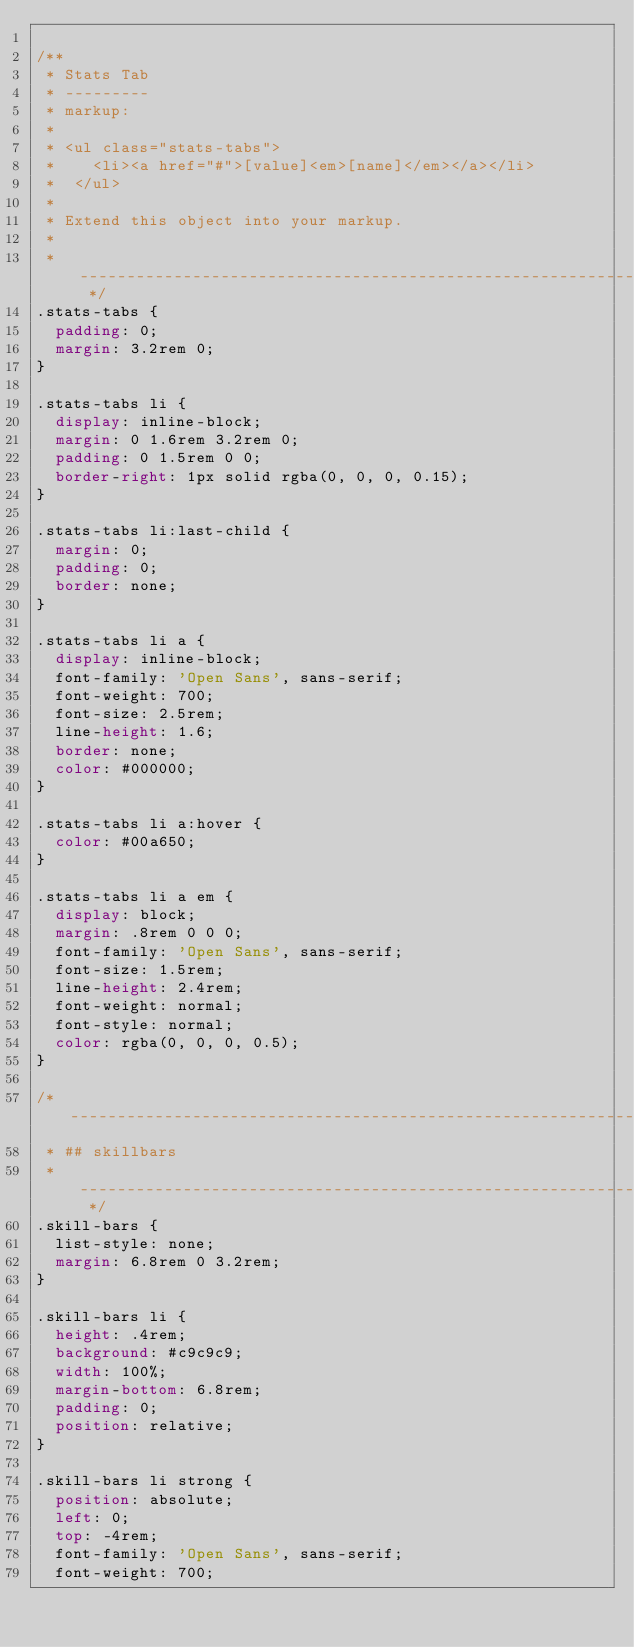Convert code to text. <code><loc_0><loc_0><loc_500><loc_500><_CSS_>
/** 
 * Stats Tab
 * ---------
 * markup:
 *
 * <ul class="stats-tabs">
 *    <li><a href="#">[value]<em>[name]</em></a></li>
 *  </ul>
 *
 * Extend this object into your markup.
 *
 * --------------------------------------------------------------------- */
.stats-tabs {
  padding: 0;
  margin: 3.2rem 0;
}

.stats-tabs li {
  display: inline-block;
  margin: 0 1.6rem 3.2rem 0;
  padding: 0 1.5rem 0 0;
  border-right: 1px solid rgba(0, 0, 0, 0.15);
}

.stats-tabs li:last-child {
  margin: 0;
  padding: 0;
  border: none;
}

.stats-tabs li a {
  display: inline-block;
  font-family: 'Open Sans', sans-serif;
  font-weight: 700;
  font-size: 2.5rem;
  line-height: 1.6;
  border: none;
  color: #000000;
}

.stats-tabs li a:hover {
  color: #00a650;
}

.stats-tabs li a em {
  display: block;
  margin: .8rem 0 0 0;
  font-family: 'Open Sans', sans-serif;
  font-size: 1.5rem;
  line-height: 2.4rem;
  font-weight: normal;
  font-style: normal;
  color: rgba(0, 0, 0, 0.5);
}

/* ------------------------------------------------------------------- 
 * ## skillbars 
 * ------------------------------------------------------------------- */
.skill-bars {
  list-style: none;
  margin: 6.8rem 0 3.2rem;
}

.skill-bars li {
  height: .4rem;
  background: #c9c9c9;
  width: 100%;
  margin-bottom: 6.8rem;
  padding: 0;
  position: relative;
}

.skill-bars li strong {
  position: absolute;
  left: 0;
  top: -4rem;
  font-family: 'Open Sans', sans-serif;
  font-weight: 700;</code> 